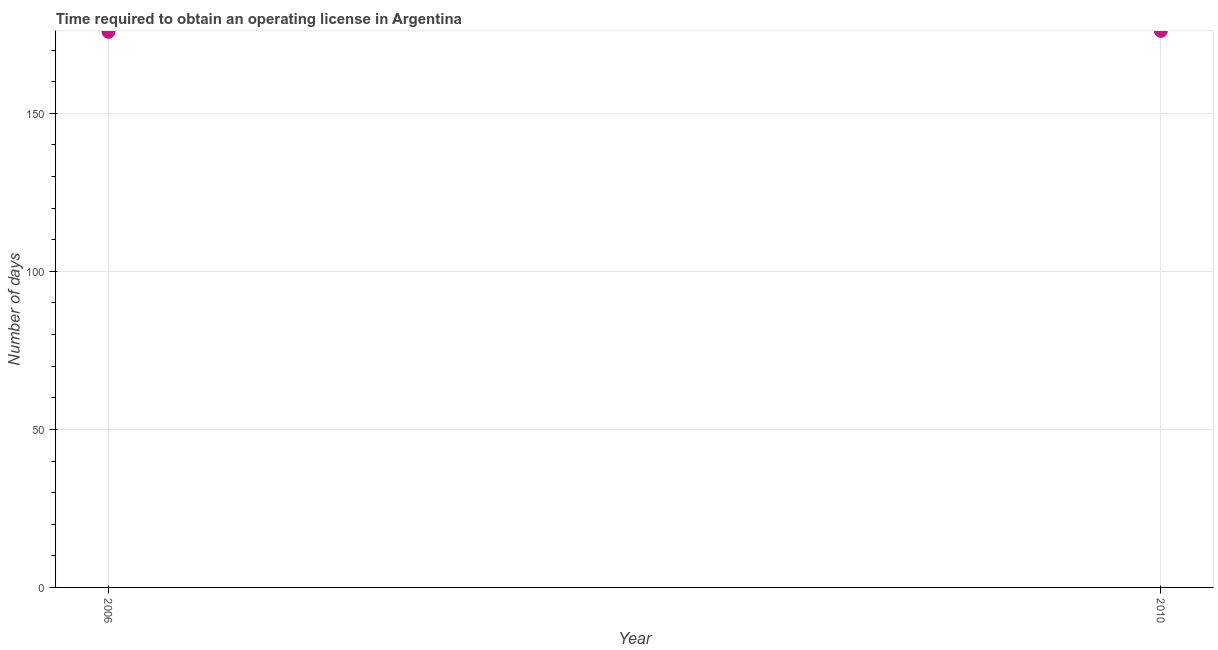What is the number of days to obtain operating license in 2010?
Your answer should be very brief. 176.1. Across all years, what is the maximum number of days to obtain operating license?
Offer a very short reply. 176.1. Across all years, what is the minimum number of days to obtain operating license?
Your answer should be compact. 175.8. In which year was the number of days to obtain operating license maximum?
Ensure brevity in your answer.  2010. In which year was the number of days to obtain operating license minimum?
Your answer should be compact. 2006. What is the sum of the number of days to obtain operating license?
Your answer should be compact. 351.9. What is the difference between the number of days to obtain operating license in 2006 and 2010?
Give a very brief answer. -0.3. What is the average number of days to obtain operating license per year?
Ensure brevity in your answer.  175.95. What is the median number of days to obtain operating license?
Provide a short and direct response. 175.95. In how many years, is the number of days to obtain operating license greater than 60 days?
Give a very brief answer. 2. What is the ratio of the number of days to obtain operating license in 2006 to that in 2010?
Your answer should be very brief. 1. Does the number of days to obtain operating license monotonically increase over the years?
Keep it short and to the point. Yes. How many dotlines are there?
Your response must be concise. 1. What is the difference between two consecutive major ticks on the Y-axis?
Your answer should be very brief. 50. Are the values on the major ticks of Y-axis written in scientific E-notation?
Give a very brief answer. No. Does the graph contain any zero values?
Give a very brief answer. No. What is the title of the graph?
Ensure brevity in your answer.  Time required to obtain an operating license in Argentina. What is the label or title of the Y-axis?
Your answer should be very brief. Number of days. What is the Number of days in 2006?
Keep it short and to the point. 175.8. What is the Number of days in 2010?
Give a very brief answer. 176.1. What is the difference between the Number of days in 2006 and 2010?
Provide a succinct answer. -0.3. 